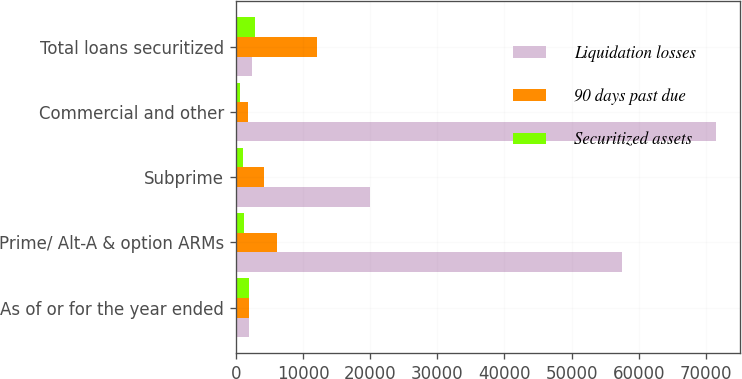<chart> <loc_0><loc_0><loc_500><loc_500><stacked_bar_chart><ecel><fcel>As of or for the year ended<fcel>Prime/ Alt-A & option ARMs<fcel>Subprime<fcel>Commercial and other<fcel>Total loans securitized<nl><fcel>Liquidation losses<fcel>2016<fcel>57543<fcel>19903<fcel>71464<fcel>2453<nl><fcel>90 days past due<fcel>2016<fcel>6169<fcel>4186<fcel>1755<fcel>12110<nl><fcel>Securitized assets<fcel>2016<fcel>1160<fcel>1087<fcel>643<fcel>2890<nl></chart> 